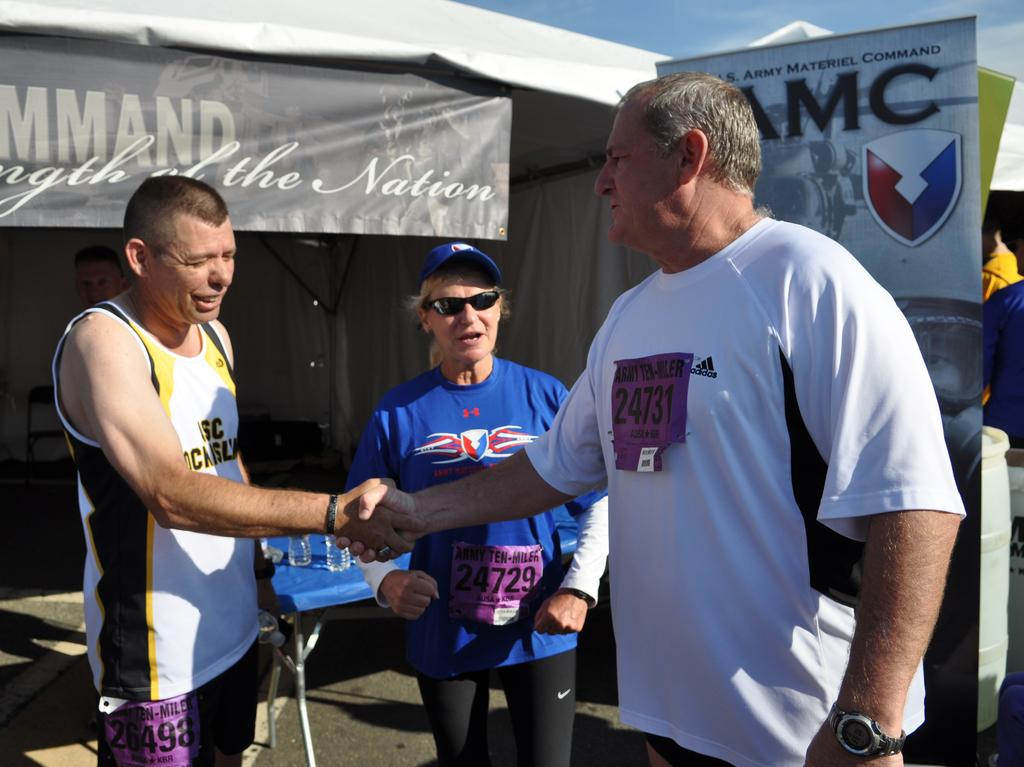<image>
Relay a brief, clear account of the picture shown. Two people shake hands, behind them is a banner about the army material command. 